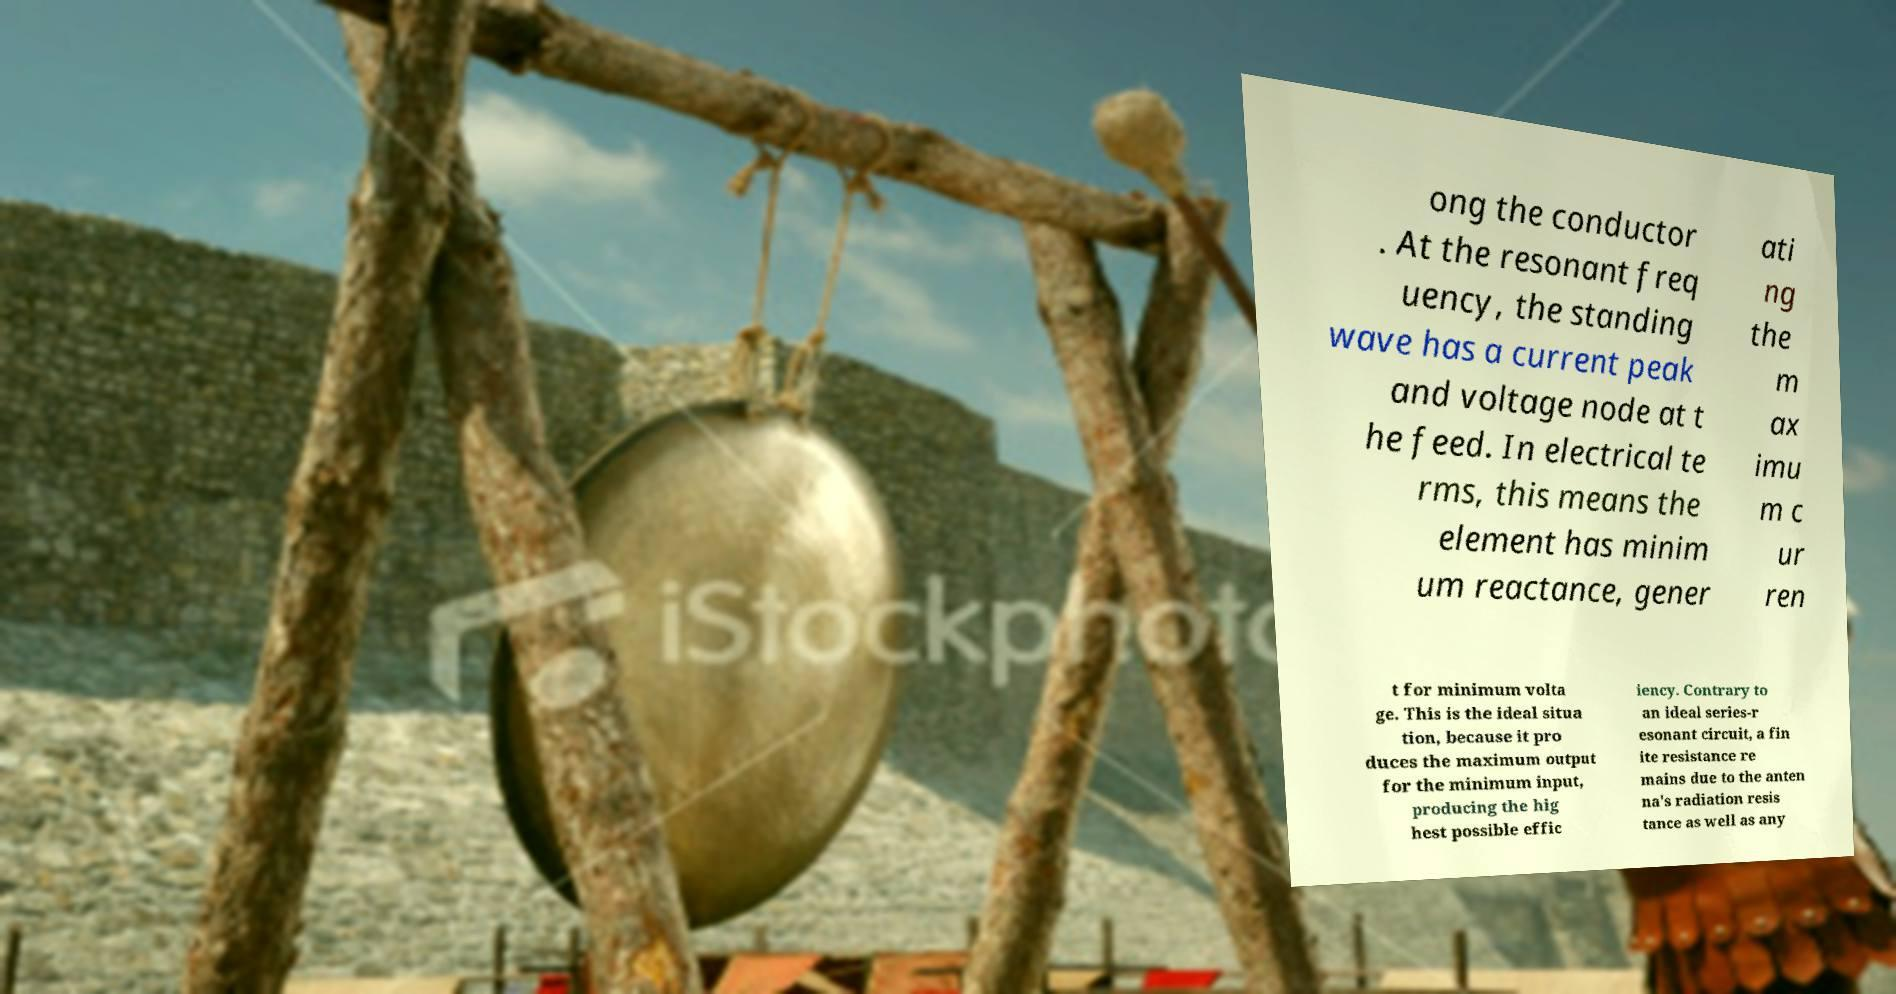Please read and relay the text visible in this image. What does it say? ong the conductor . At the resonant freq uency, the standing wave has a current peak and voltage node at t he feed. In electrical te rms, this means the element has minim um reactance, gener ati ng the m ax imu m c ur ren t for minimum volta ge. This is the ideal situa tion, because it pro duces the maximum output for the minimum input, producing the hig hest possible effic iency. Contrary to an ideal series-r esonant circuit, a fin ite resistance re mains due to the anten na's radiation resis tance as well as any 